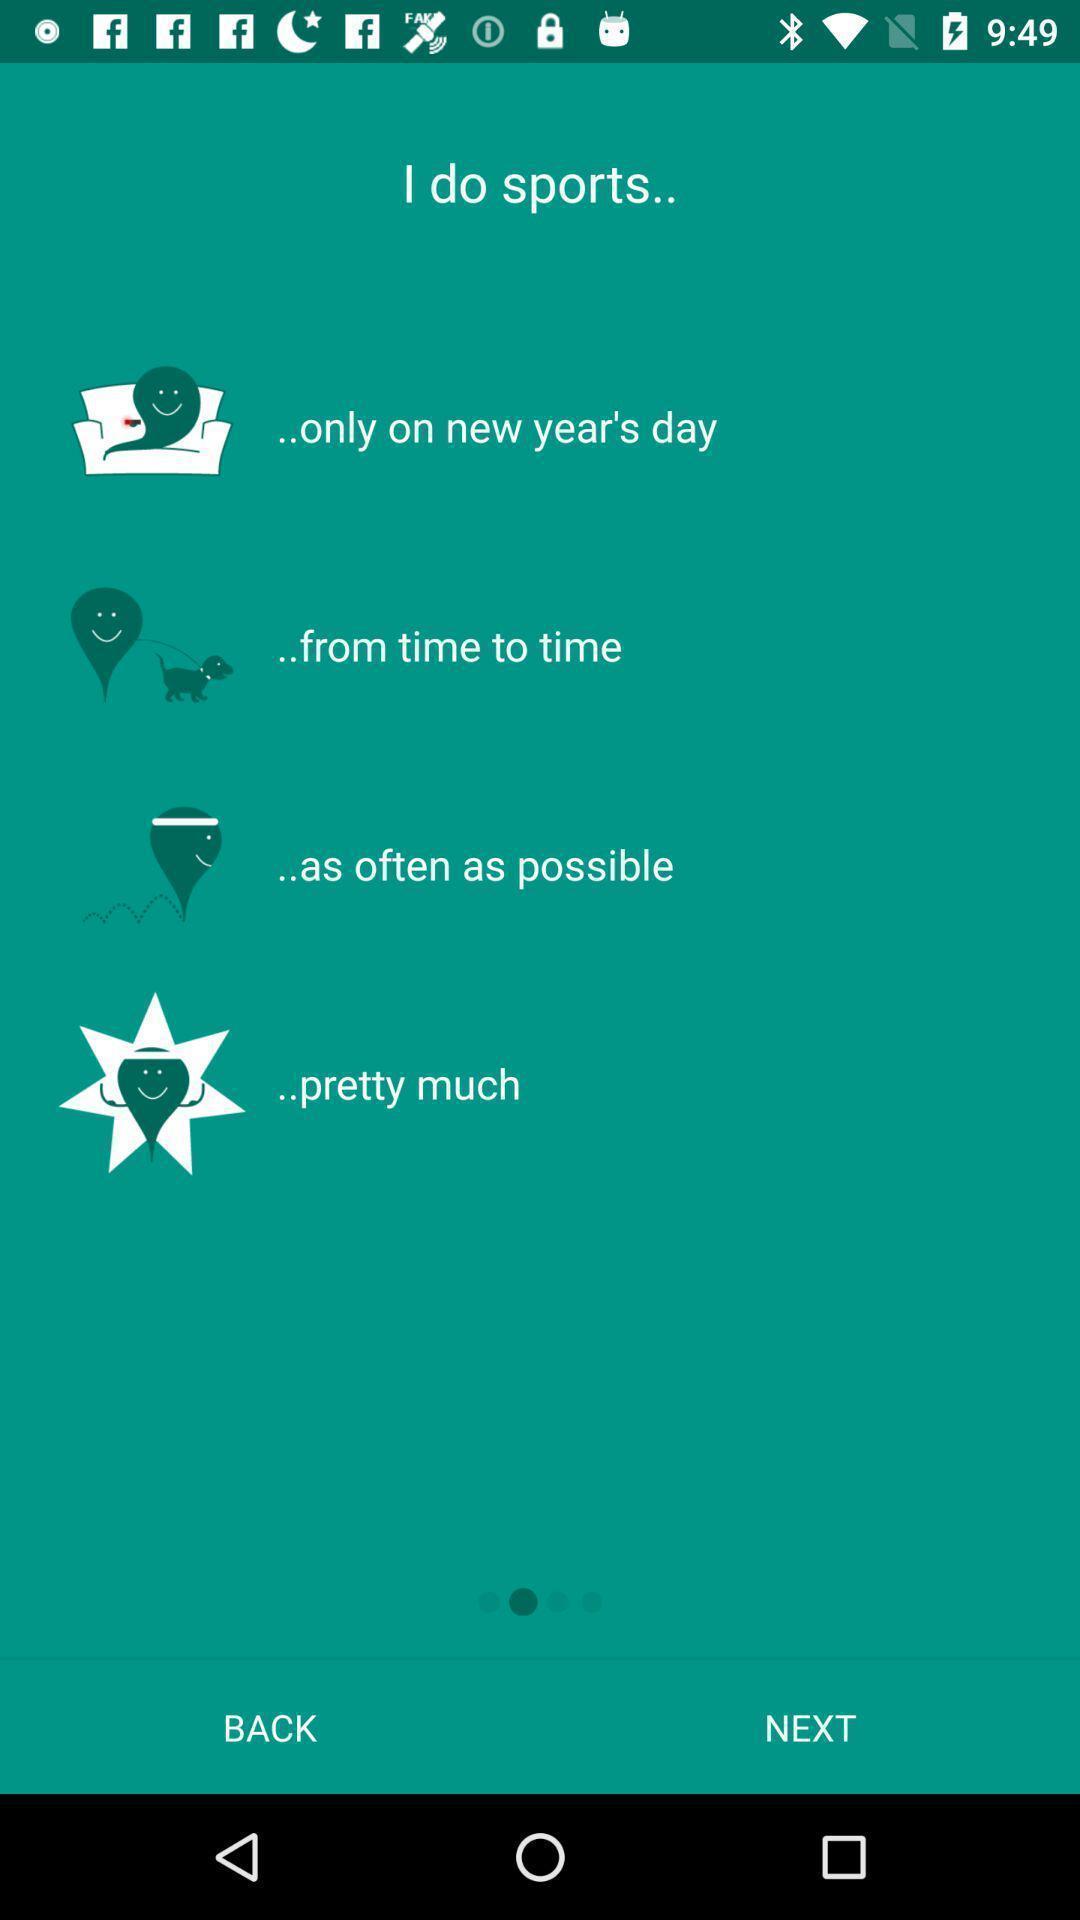Describe this image in words. Welcome page asking queries in a fitness app. 